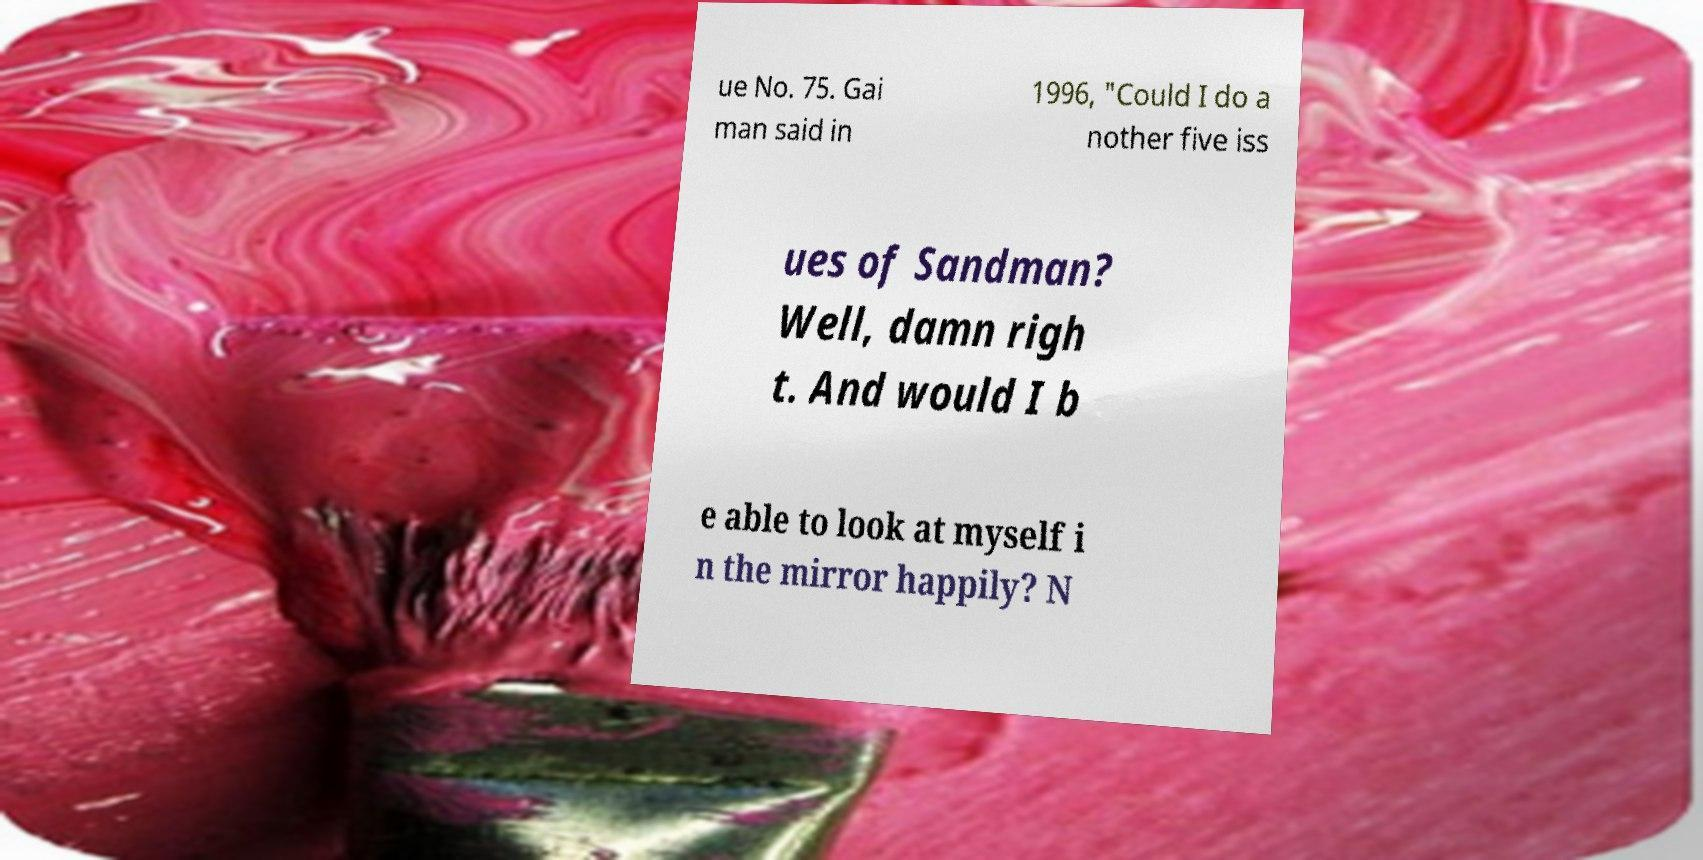I need the written content from this picture converted into text. Can you do that? ue No. 75. Gai man said in 1996, "Could I do a nother five iss ues of Sandman? Well, damn righ t. And would I b e able to look at myself i n the mirror happily? N 